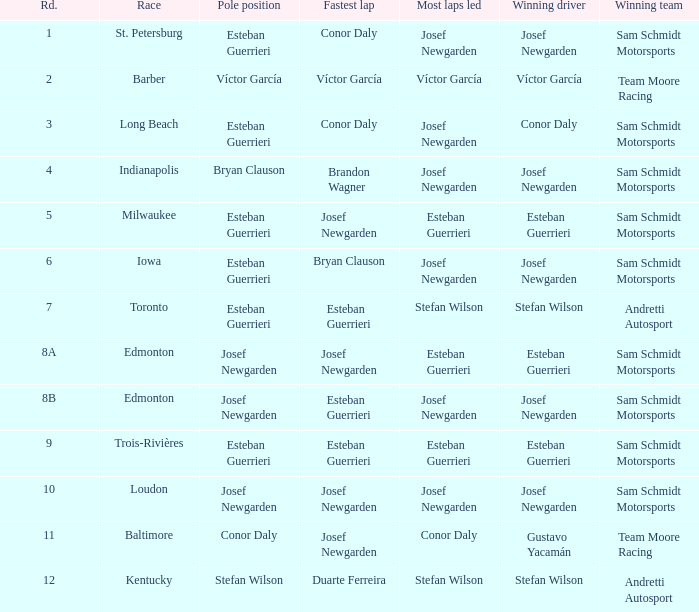In what contest did josef newgarden register the fastest lap time and maintain the lead for the majority of laps? Loudon. 